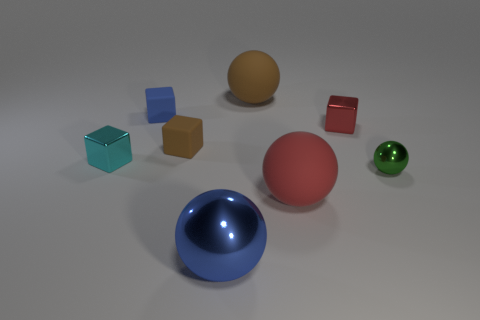Add 2 gray spheres. How many objects exist? 10 Subtract all red spheres. How many spheres are left? 3 Subtract all red spheres. How many spheres are left? 3 Subtract all brown balls. Subtract all yellow cylinders. How many balls are left? 3 Subtract all blue blocks. How many green spheres are left? 1 Subtract all small brown metal blocks. Subtract all blue shiny spheres. How many objects are left? 7 Add 5 big red objects. How many big red objects are left? 6 Add 5 brown spheres. How many brown spheres exist? 6 Subtract 0 red cylinders. How many objects are left? 8 Subtract 2 cubes. How many cubes are left? 2 